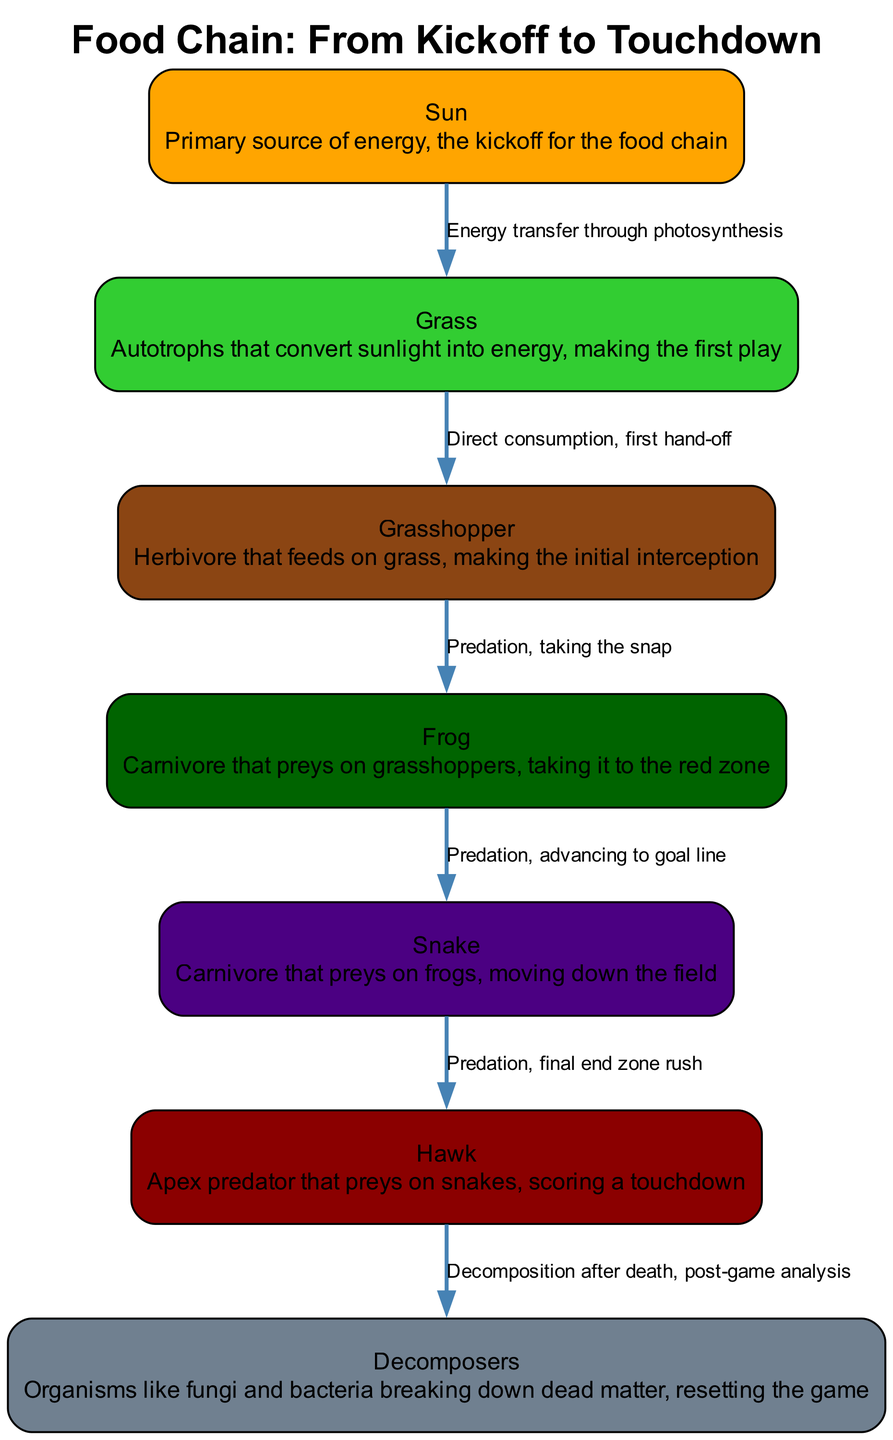What is the starting point of the food chain? The food chain begins with the "Sun," which is the primary source of energy. This is explicitly mentioned in the diagram where it is the first node listed.
Answer: Sun How many nodes are present in the food chain? By counting the elements in the "food_chain_elements" list, we can identify there are a total of 7 nodes, including the Sun, Grass, Grasshopper, Frog, Snake, Hawk, and Decomposers.
Answer: 7 Which organism serves as the apex predator in the food chain? The apex predator in this food chain is the "Hawk," which preys on the Snake and is positioned at the top of the hierarchy, indicating its role as the highest predator.
Answer: Hawk What type of relationship exists between Grass and Grasshopper? The relationship is defined as "Direct consumption, first hand-off" indicating that Grass is consumed by the Grasshopper, which is a primary consumer. This is shown as the edge connecting these two nodes.
Answer: Direct consumption What happens to a Hawk after death according to the food chain diagram? According to the diagram, after a Hawk dies, "Decomposers" break down its dead matter, which signifies the resetting of the ecosystem. This relationship is depicted by an edge going to the Decomposers node.
Answer: Decomposers Which level does the Frog occupy in the food chain hierarchy? The Frog is a carnivore and primarily preys on Grasshoppers, placing it in the second-level trophic position in the food chain. It is the second predator after the Herbivore stage.
Answer: Second-level carnivore How does energy transfer occur from the Sun to Grass? Energy transfer occurs through a process called "photosynthesis," where Grass utilizes sunlight to convert it into energy, establishing the foundational layer in the food chain. This is elaborated in the edge description between these two nodes.
Answer: Photosynthesis What is the function of decomposers in the food chain? Decomposers, like fungi and bacteria, serve the essential function of breaking down dead organic matter, thus recycling nutrients back into the ecosystem and resetting the game for new life. This is indicated in the "Decomposers" node description.
Answer: Breaking down dead matter 